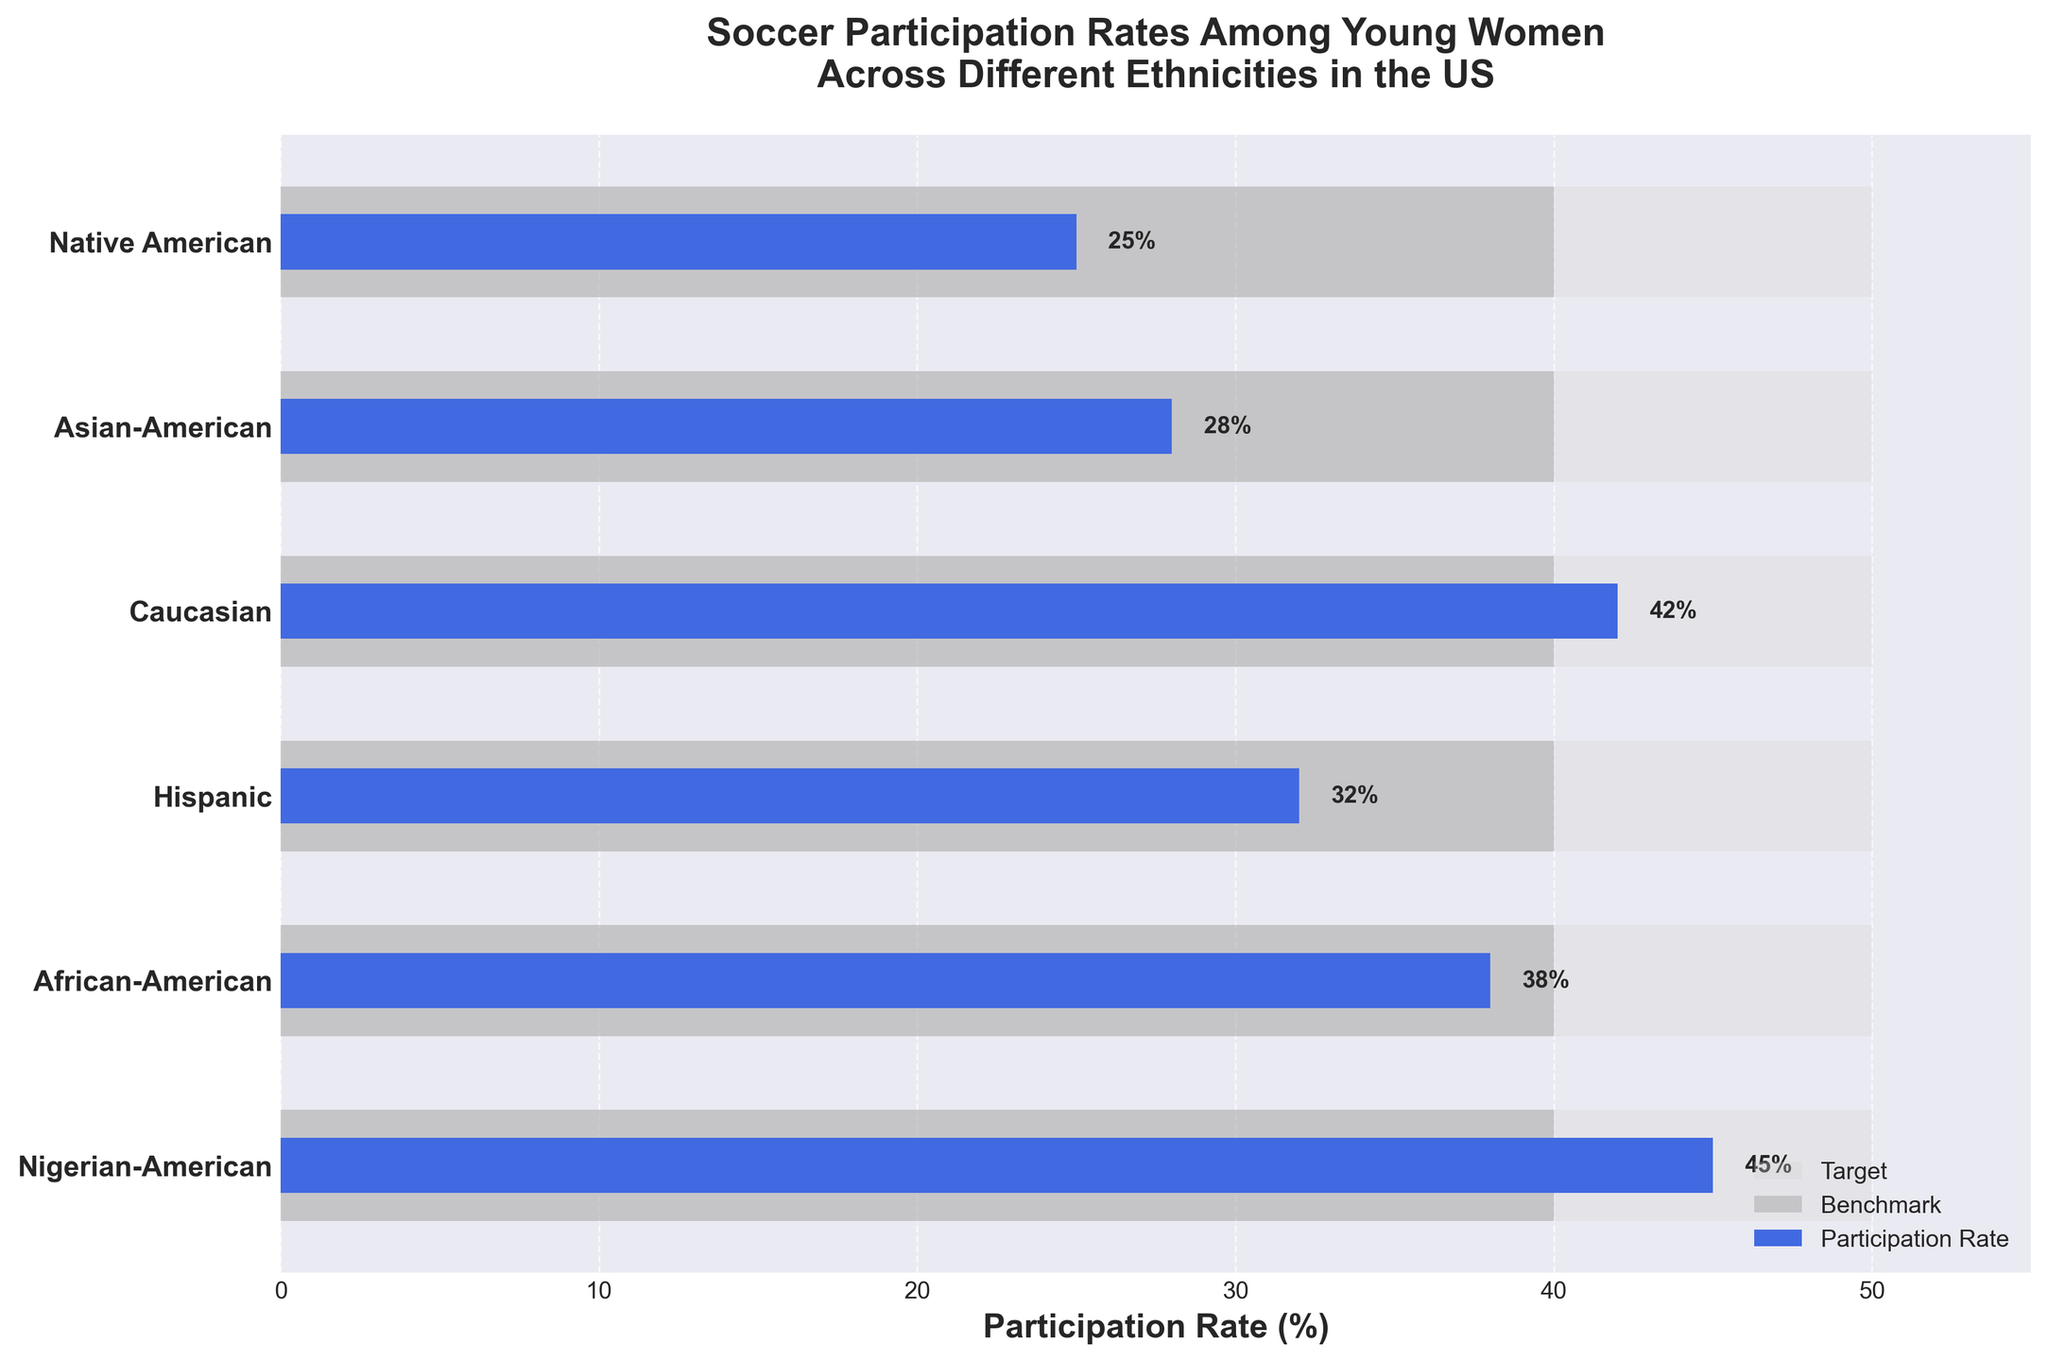What's the title of the chart? The title is located at the top of the chart and gives an overview of what the chart represents. It reads "Soccer Participation Rates Among Young Women Across Different Ethnicities in the US."
Answer: Soccer Participation Rates Among Young Women Across Different Ethnicities in the US Which ethnicity has the highest participation rate? By looking at the blue bars, which indicate the participation rates, Nigerian-American women have the longest bar, indicating the highest participation rate of 45%.
Answer: Nigerian-American What is the participation rate for Asian-American women? The blue bar corresponding to Asian-American women shows a value, and the label next to it confirms it. The participation rate for Asian-American women is 28%.
Answer: 28% Are any ethnicities meeting the target participation rate of 50%? The target rate is indicated by the light grey bars. By comparing the blue bars to the light grey bars, none of the blue bars reach the 50% target.
Answer: No How does the participation rate for Hispanic women compare to the benchmark? The benchmark participation rate is shown by dark grey bars set at 40%. The blue bar for Hispanic women, which is at 32%, falls short of the 40% benchmark by 8%.
Answer: 8% below What's the range of participation rates among the listed ethnicities? The highest rate is for Nigerian-American at 45% and the lowest is for Native American at 25%. The range is calculated as 45% - 25% = 20%.
Answer: 20% Which ethnicities have participation rates above the benchmark? The benchmark is indicated by the dark grey bar set at 40%. Only Nigerian-American women at 45% and Caucasian women at 42% have participation rates above this benchmark.
Answer: Nigerian-American and Caucasian How close are African-American women to reaching the target of 50%? African-American women have a participation rate of 38%. The target is 50%, so the difference is 50% - 38% = 12%.
Answer: 12% below What is the difference in participation rates between the ethnicity with the highest rate and the lowest rate? The highest participation rate is for Nigerian-American women at 45%, and the lowest is for Native American women at 25%. The difference is 45% - 25% = 20%.
Answer: 20% How many ethnicities have participation rates lower than the benchmark? The benchmark participation rate is indicated by dark grey bars at 40%. By comparing the blue bars, African-American, Hispanic, Asian-American, and Native American women all have rates lower than 40%. The total count is 4.
Answer: 4 